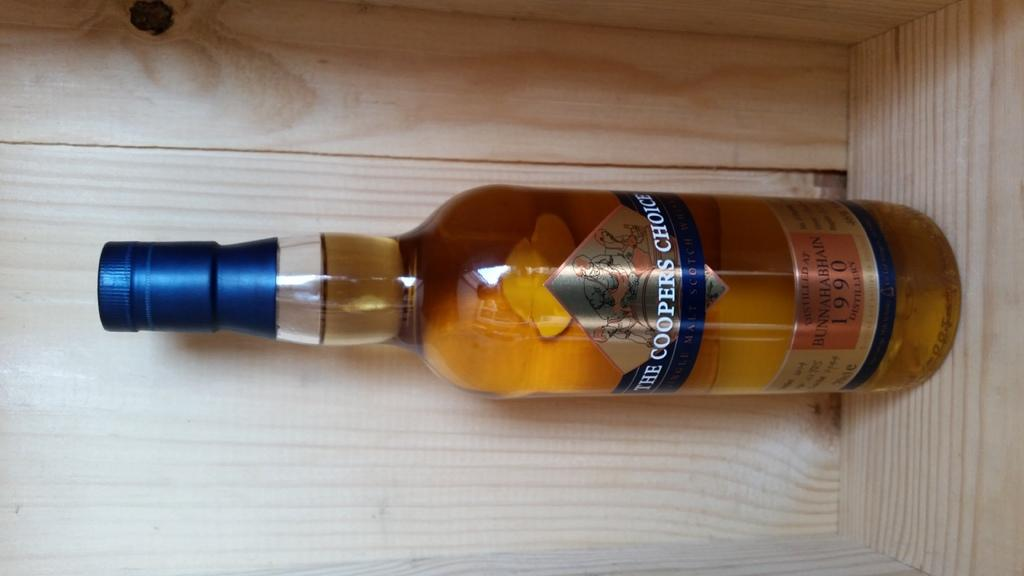<image>
Relay a brief, clear account of the picture shown. An unopened bottle of The Coopers Choice liquor . 